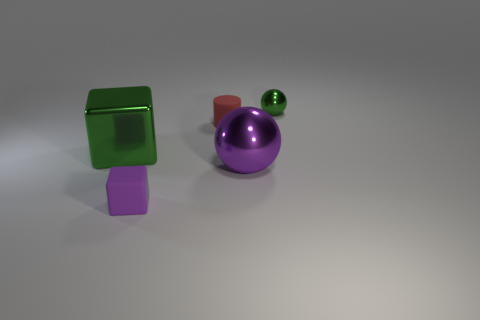Add 2 big metallic blocks. How many objects exist? 7 Subtract all green spheres. How many spheres are left? 1 Subtract all balls. How many objects are left? 3 Subtract 2 spheres. How many spheres are left? 0 Subtract all brown blocks. Subtract all yellow balls. How many blocks are left? 2 Subtract all green shiny blocks. Subtract all purple shiny things. How many objects are left? 3 Add 2 large metallic blocks. How many large metallic blocks are left? 3 Add 2 big things. How many big things exist? 4 Subtract 0 brown cylinders. How many objects are left? 5 